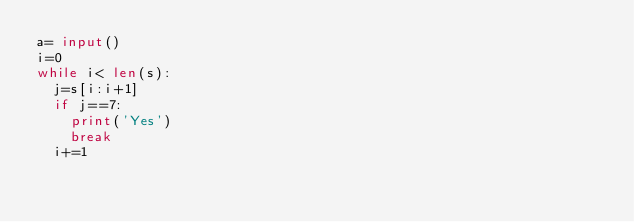<code> <loc_0><loc_0><loc_500><loc_500><_Python_>a= input()
i=0
while i< len(s):
  j=s[i:i+1]
  if j==7:
    print('Yes')
    break
  i+=1</code> 